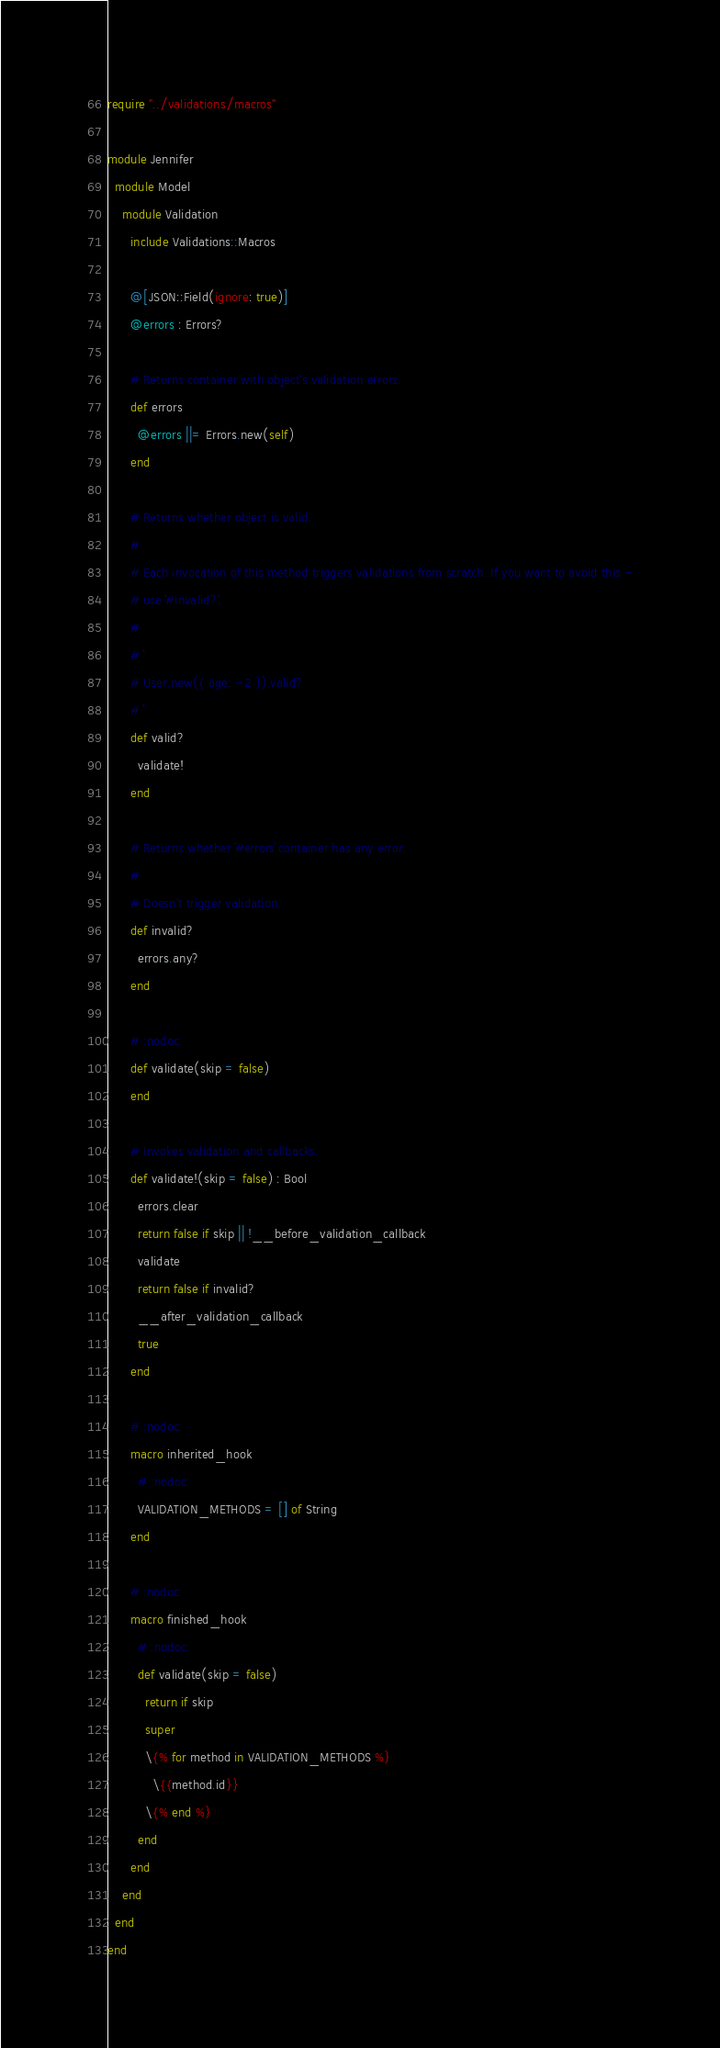<code> <loc_0><loc_0><loc_500><loc_500><_Crystal_>require "../validations/macros"

module Jennifer
  module Model
    module Validation
      include Validations::Macros

      @[JSON::Field(ignore: true)]
      @errors : Errors?

      # Returns container with object's validation errors.
      def errors
        @errors ||= Errors.new(self)
      end

      # Returns whether object is valid.
      #
      # Each invocation of this method triggers validations from scratch. If you want to avoid this -
      # use `#invalid?`.
      #
      # ```
      # User.new({ age: -2 }).valid?
      # ```
      def valid?
        validate!
      end

      # Returns whether `#errors` container has any error.
      #
      # Doesn't trigger validation.
      def invalid?
        errors.any?
      end

      # :nodoc:
      def validate(skip = false)
      end

      # Invokes validation and callbacks.
      def validate!(skip = false) : Bool
        errors.clear
        return false if skip || !__before_validation_callback
        validate
        return false if invalid?
        __after_validation_callback
        true
      end

      # :nodoc:
      macro inherited_hook
        # :nodoc:
        VALIDATION_METHODS = [] of String
      end

      # :nodoc:
      macro finished_hook
        # :nodoc:
        def validate(skip = false)
          return if skip
          super
          \{% for method in VALIDATION_METHODS %}
            \{{method.id}}
          \{% end %}
        end
      end
    end
  end
end
</code> 